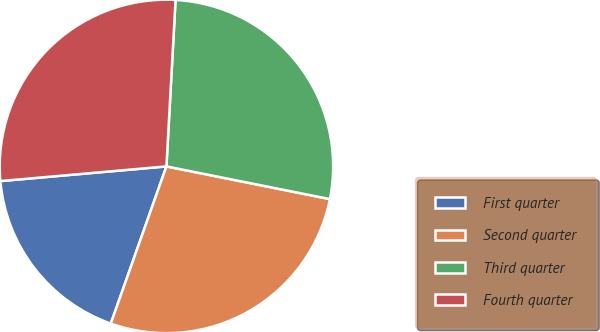Convert chart to OTSL. <chart><loc_0><loc_0><loc_500><loc_500><pie_chart><fcel>First quarter<fcel>Second quarter<fcel>Third quarter<fcel>Fourth quarter<nl><fcel>18.18%<fcel>27.27%<fcel>27.27%<fcel>27.27%<nl></chart> 